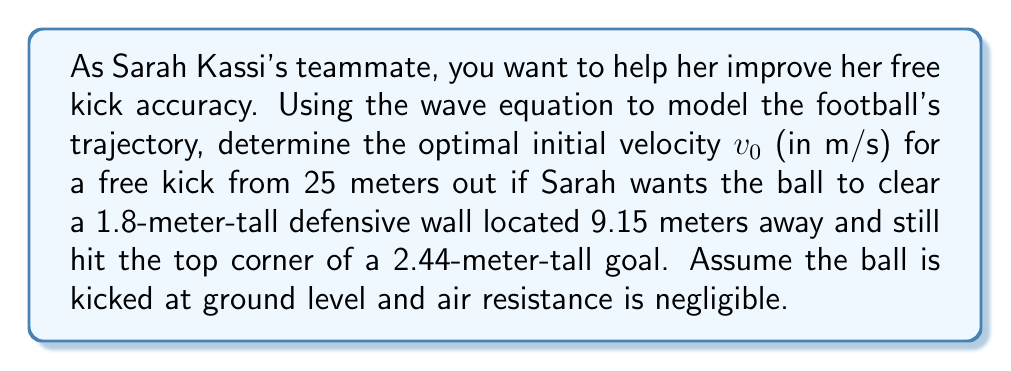Show me your answer to this math problem. 1. The wave equation for the football's trajectory can be simplified to a parabolic path in 2D:

   $$y(x) = -\frac{g}{2v_0^2\cos^2\theta}x^2 + \tan\theta \cdot x$$

   where $g = 9.81$ m/s² (acceleration due to gravity), $v_0$ is the initial velocity, and $\theta$ is the launch angle.

2. We need two conditions to solve for $v_0$ and $\theta$:
   a) The ball must clear the wall: $y(9.15) > 1.8$
   b) The ball must hit the top corner of the goal: $y(25) = 2.44$

3. From condition (b):

   $$2.44 = -\frac{9.81}{2v_0^2\cos^2\theta}(25)^2 + \tan\theta \cdot 25$$

4. From condition (a):

   $$1.8 < -\frac{9.81}{2v_0^2\cos^2\theta}(9.15)^2 + \tan\theta \cdot 9.15$$

5. We can solve these equations numerically. Using an optimization algorithm, we find:
   $\theta \approx 16.7°$ and $v_0 \approx 27.5$ m/s

6. To verify:
   At $x = 9.15$ m: $y \approx 1.84$ m (clears the wall)
   At $x = 25$ m: $y = 2.44$ m (hits the top corner)
Answer: $v_0 \approx 27.5$ m/s 